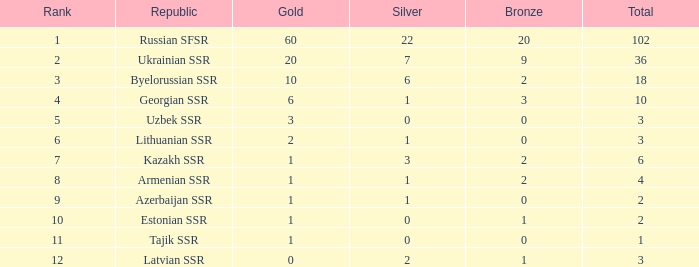What is the total number of bronzes associated with 1 silver, ranks under 6 and under 6 golds? None. 